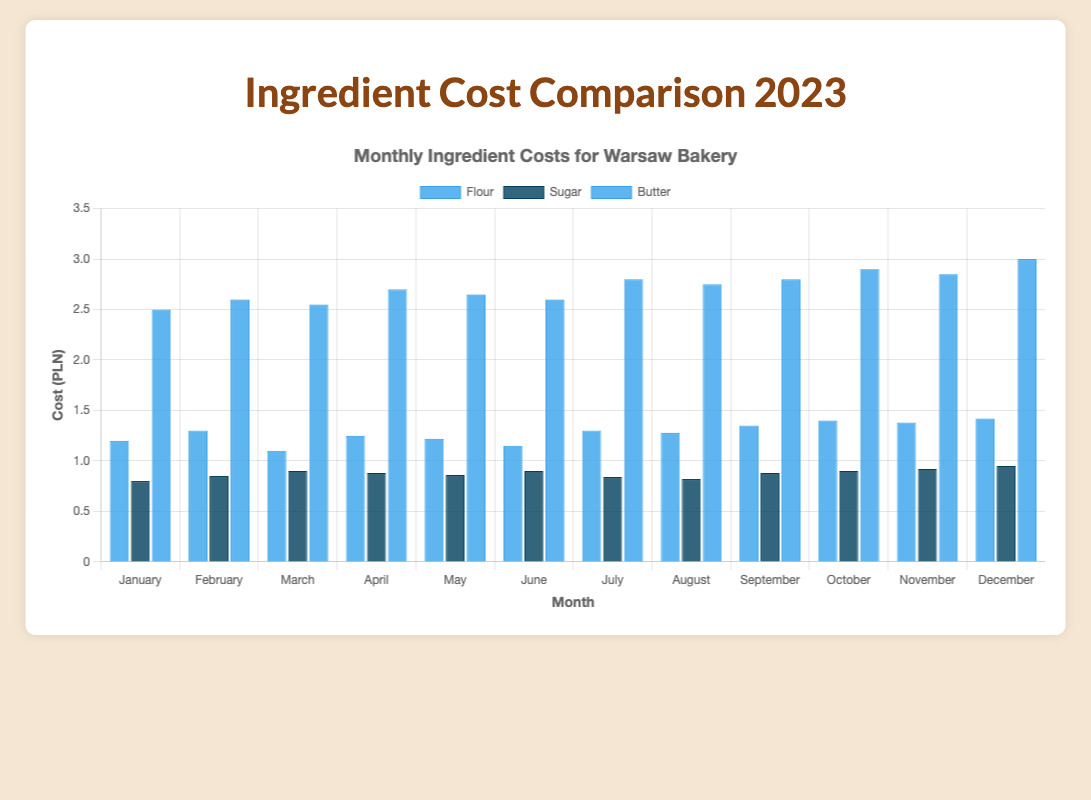Which month had the highest cost for Butter? By looking at the bar heights, the highest bar for Butter is in December, indicating that's the month with the highest cost.
Answer: December What is the cost difference between Flour and Sugar in October? The cost of Flour in October is 1.4 and the cost of Sugar in October is 0.9. The difference is 1.4 - 0.9 = 0.5.
Answer: 0.5 During which months was the cost of Flour greater than 1.35? By observing the heights of the Flour bars, Flour costs greater than 1.35 occur in September, October, November, and December.
Answer: September, October, November, December How did the cost of Butter change from March to April? The cost of Butter in March is 2.55, and in April, it is 2.7. The difference is 2.7 - 2.55 = 0.15.
Answer: Increased by 0.15 What was the average cost of Sugar in the first quarter (January to March)? The costs of Sugar in January, February, and March are 0.8, 0.85, and 0.9, respectively. The sum is 0.8 + 0.85 + 0.9 = 2.55, divided by 3 to get the average: 2.55 / 3 = 0.85.
Answer: 0.85 Which ingredient had the highest cost in June? By comparing the bar heights for June, Butter has the highest bar, indicating it has the highest cost among the three ingredients.
Answer: Butter How many months had a Flour cost of exactly 1.3? Observing the Flour bars, February, July, and September show a cost of exactly 1.3.
Answer: 3 What was the total cost of Butter from January to December? Summing up monthly Butter costs: 2.5 + 2.6 + 2.55 + 2.7 + 2.65 + 2.6 + 2.8 + 2.75 + 2.8 + 2.9 + 2.85 + 3.0 = 33.7.
Answer: 33.7 Which month had the lowest overall ingredient costs (considering Flour, Sugar, and Butter combined)? Calculate the total cost for each month and identify the lowest. January: 1.2 + 0.8 + 2.5 = 4.5. February: 1.3 + 0.85 + 2.6 = 4.75. March: 1.1 + 0.9 + 2.55 = 4.55. April: 1.25 + 0.88 + 2.7 = 4.83. May: 1.22 + 0.86 + 2.65 = 4.73. June: 1.15 + 0.9 + 2.6 = 4.65. July: 1.3 + 0.84 + 2.8 = 4.94. August: 1.28 + 0.82 + 2.75 = 4.85. September: 1.35 + 0.88 + 2.8 = 5.03. October: 1.4 + 0.9 + 2.9 = 5.2. November: 1.38 + 0.92 + 2.85 = 5.15. December: 1.42 + 0.95 + 3.0 = 5.37. The lowest total cost is in January.
Answer: January 